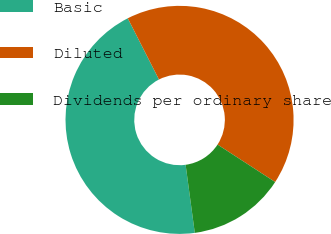Convert chart. <chart><loc_0><loc_0><loc_500><loc_500><pie_chart><fcel>Basic<fcel>Diluted<fcel>Dividends per ordinary share<nl><fcel>44.63%<fcel>41.67%<fcel>13.69%<nl></chart> 